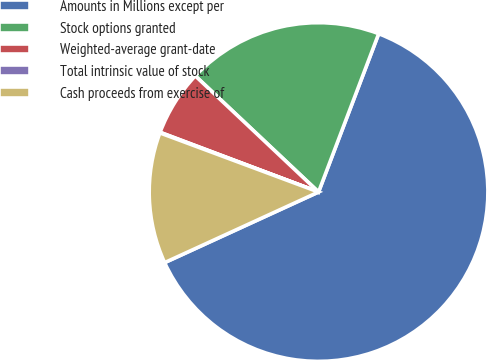<chart> <loc_0><loc_0><loc_500><loc_500><pie_chart><fcel>Amounts in Millions except per<fcel>Stock options granted<fcel>Weighted-average grant-date<fcel>Total intrinsic value of stock<fcel>Cash proceeds from exercise of<nl><fcel>62.37%<fcel>18.75%<fcel>6.29%<fcel>0.06%<fcel>12.52%<nl></chart> 